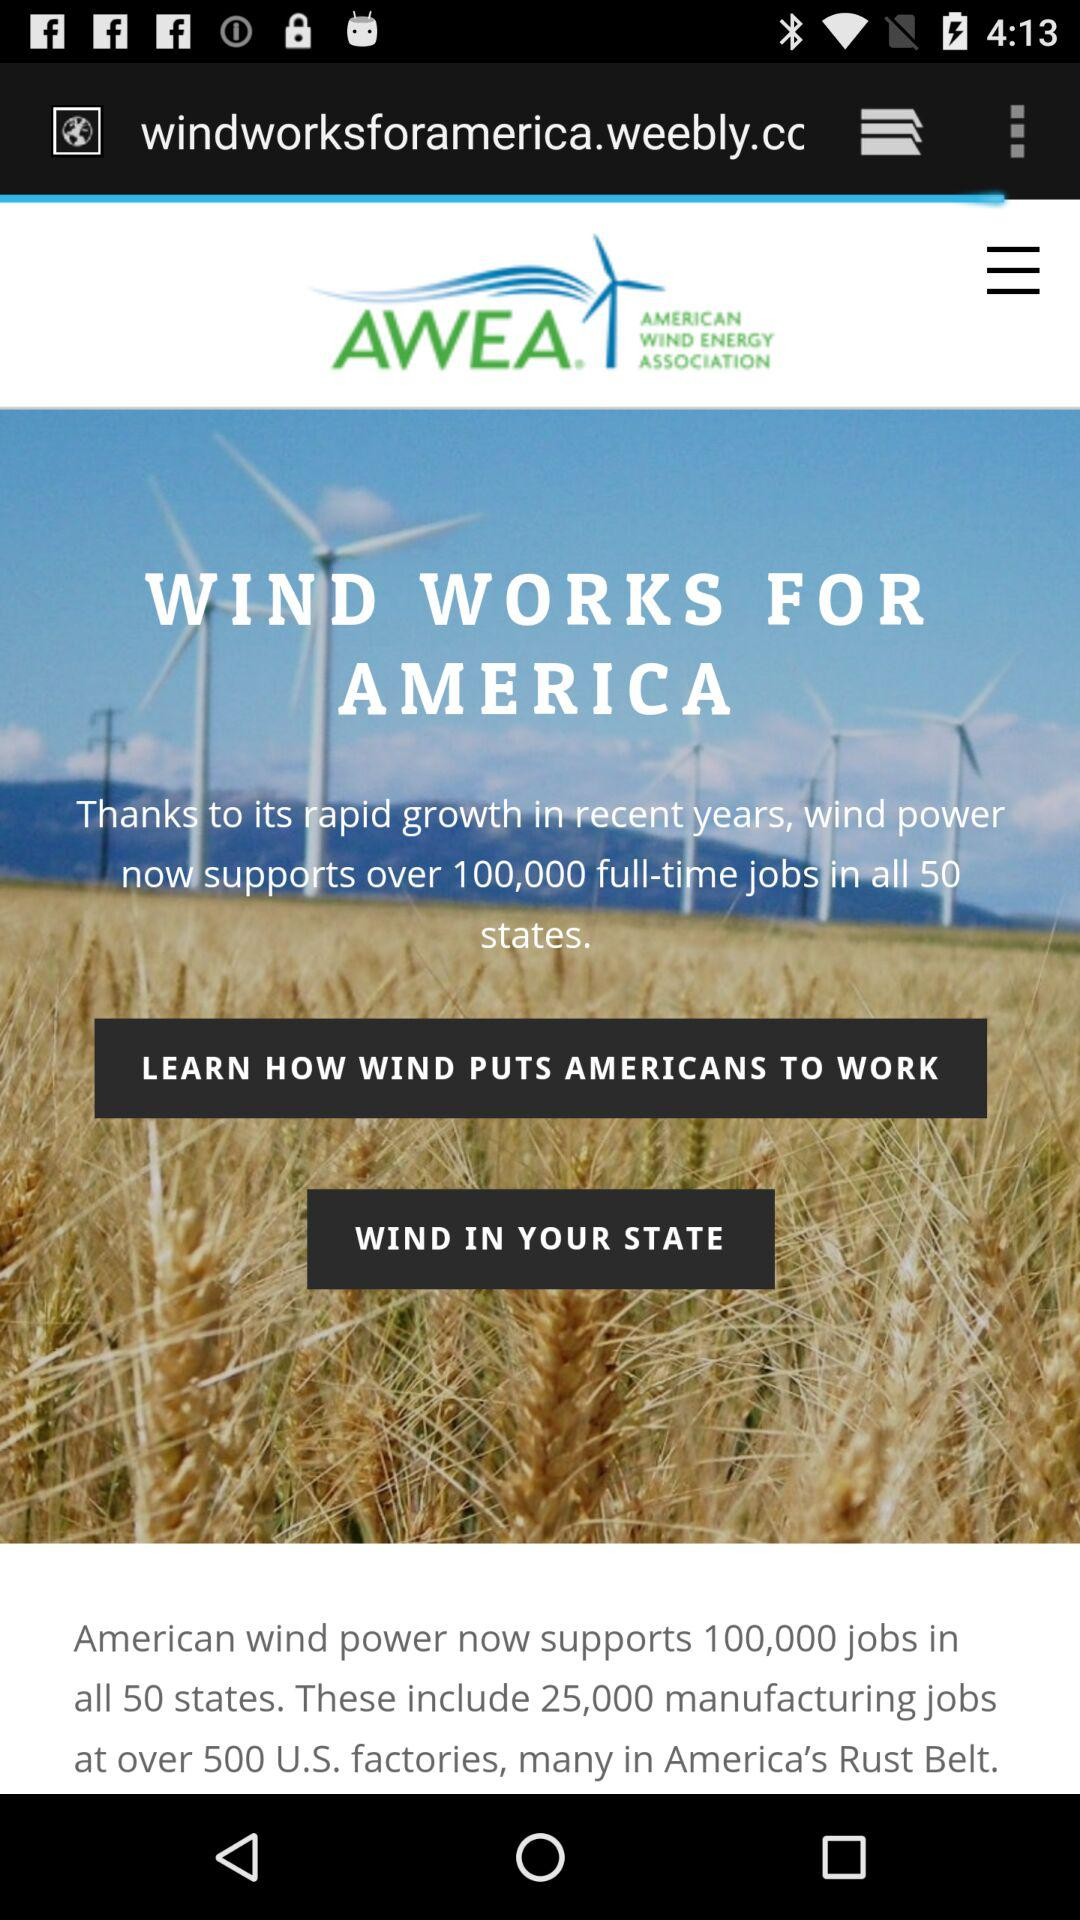What is the name of the application? The name of the application is "AWEA". 